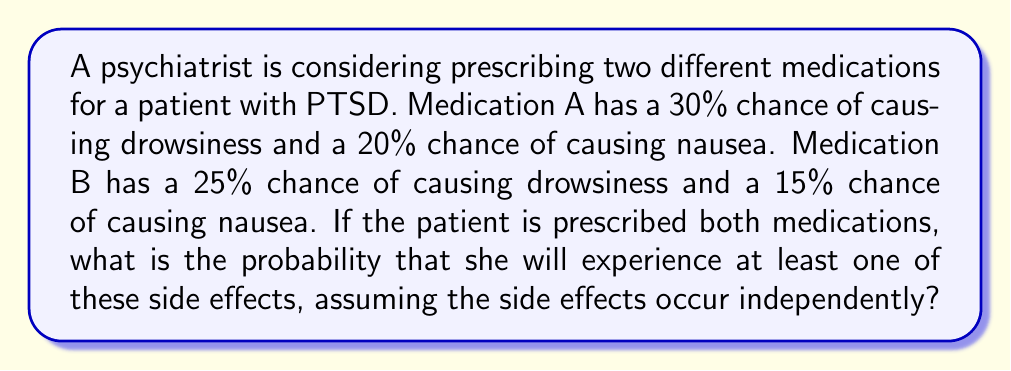Can you answer this question? Let's approach this step-by-step using set theory:

1) Let's define our sets:
   $D_A$ = event of drowsiness from Medication A
   $N_A$ = event of nausea from Medication A
   $D_B$ = event of drowsiness from Medication B
   $N_B$ = event of nausea from Medication B

2) We're given the following probabilities:
   $P(D_A) = 0.30$
   $P(N_A) = 0.20$
   $P(D_B) = 0.25$
   $P(N_B) = 0.15$

3) We want to find the probability of experiencing at least one side effect. This is equivalent to finding the probability of the union of all these events:

   $P(D_A \cup N_A \cup D_B \cup N_B)$

4) To calculate this, it's easier to find the probability of not experiencing any side effects and then subtract from 1:

   $P(D_A \cup N_A \cup D_B \cup N_B) = 1 - P(\overline{D_A} \cap \overline{N_A} \cap \overline{D_B} \cap \overline{N_B})$

5) Assuming independence, we can multiply the probabilities of not experiencing each side effect:

   $P(\overline{D_A} \cap \overline{N_A} \cap \overline{D_B} \cap \overline{N_B}) = (1-0.30)(1-0.20)(1-0.25)(1-0.15)$

6) Let's calculate:
   $(0.70)(0.80)(0.75)(0.85) = 0.3570$

7) Therefore, the probability of experiencing at least one side effect is:

   $1 - 0.3570 = 0.6430$ or 64.30%
Answer: The probability that the patient will experience at least one of these side effects is 0.6430 or 64.30%. 